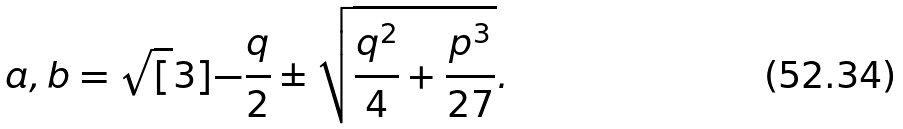Convert formula to latex. <formula><loc_0><loc_0><loc_500><loc_500>a , b = \sqrt { [ } 3 ] { - \frac { q } { 2 } \pm \sqrt { \frac { q ^ { 2 } } { 4 } + \frac { p ^ { 3 } } { 2 7 } } } .</formula> 